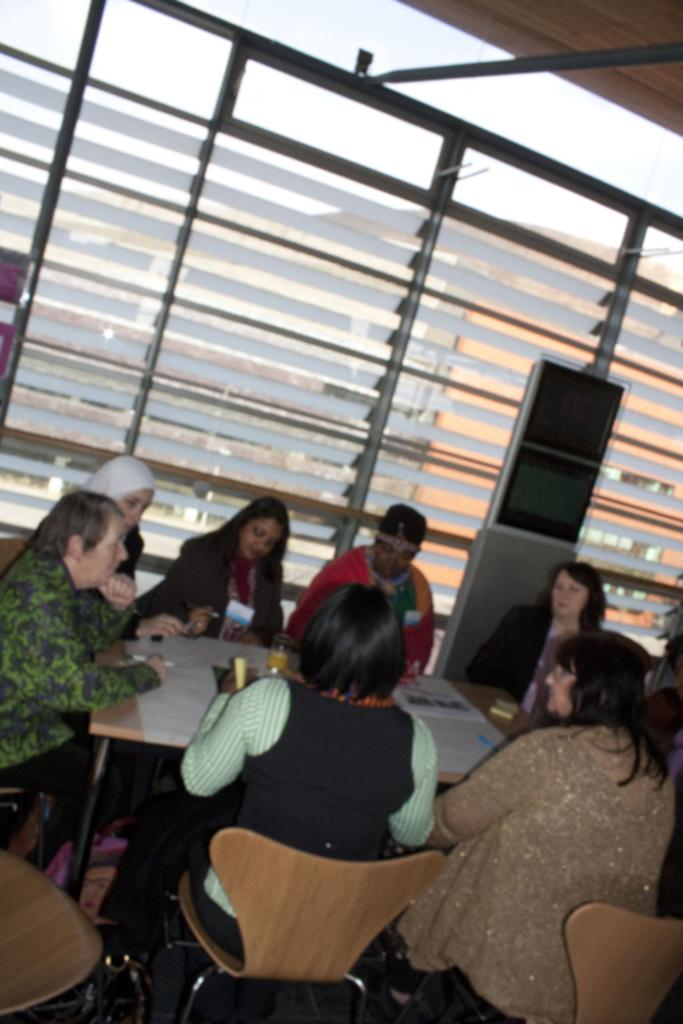What are the people in the image doing? The people in the image are sitting on chairs. How are the chairs arranged in the image? The chairs are arranged around a table. What can be seen in the background of the image? There are glass windows in the background of the image. What type of celery is being used as a centerpiece on the table in the image? There is no celery present in the image; it only shows people sitting on chairs around a table. 